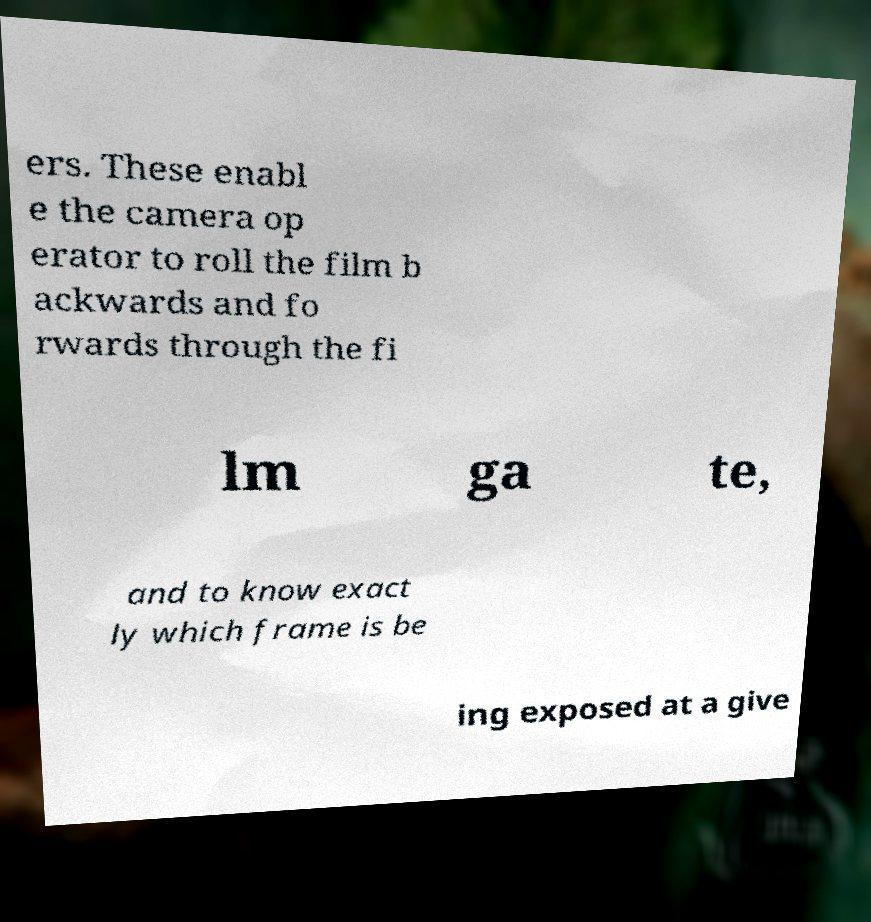Please read and relay the text visible in this image. What does it say? ers. These enabl e the camera op erator to roll the film b ackwards and fo rwards through the fi lm ga te, and to know exact ly which frame is be ing exposed at a give 